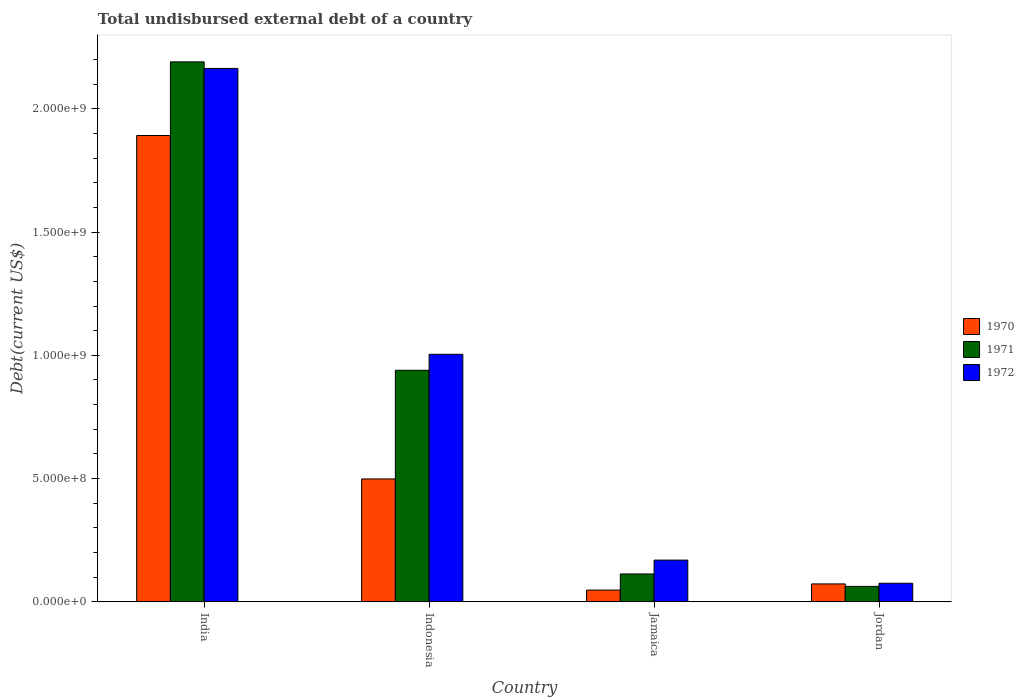How many different coloured bars are there?
Your answer should be very brief. 3. How many groups of bars are there?
Ensure brevity in your answer.  4. Are the number of bars per tick equal to the number of legend labels?
Your response must be concise. Yes. Are the number of bars on each tick of the X-axis equal?
Give a very brief answer. Yes. How many bars are there on the 2nd tick from the left?
Your response must be concise. 3. How many bars are there on the 1st tick from the right?
Offer a very short reply. 3. What is the label of the 3rd group of bars from the left?
Give a very brief answer. Jamaica. In how many cases, is the number of bars for a given country not equal to the number of legend labels?
Offer a very short reply. 0. What is the total undisbursed external debt in 1970 in Jordan?
Provide a succinct answer. 7.28e+07. Across all countries, what is the maximum total undisbursed external debt in 1971?
Provide a succinct answer. 2.19e+09. Across all countries, what is the minimum total undisbursed external debt in 1971?
Your answer should be very brief. 6.28e+07. In which country was the total undisbursed external debt in 1970 minimum?
Offer a very short reply. Jamaica. What is the total total undisbursed external debt in 1971 in the graph?
Ensure brevity in your answer.  3.31e+09. What is the difference between the total undisbursed external debt in 1970 in Indonesia and that in Jordan?
Your response must be concise. 4.26e+08. What is the difference between the total undisbursed external debt in 1970 in Jamaica and the total undisbursed external debt in 1972 in India?
Keep it short and to the point. -2.12e+09. What is the average total undisbursed external debt in 1970 per country?
Your answer should be very brief. 6.28e+08. What is the difference between the total undisbursed external debt of/in 1971 and total undisbursed external debt of/in 1972 in Jordan?
Ensure brevity in your answer.  -1.28e+07. In how many countries, is the total undisbursed external debt in 1970 greater than 600000000 US$?
Provide a succinct answer. 1. What is the ratio of the total undisbursed external debt in 1972 in Jamaica to that in Jordan?
Offer a terse response. 2.24. Is the total undisbursed external debt in 1972 in India less than that in Jamaica?
Provide a short and direct response. No. Is the difference between the total undisbursed external debt in 1971 in Indonesia and Jordan greater than the difference between the total undisbursed external debt in 1972 in Indonesia and Jordan?
Give a very brief answer. No. What is the difference between the highest and the second highest total undisbursed external debt in 1971?
Offer a terse response. 8.26e+08. What is the difference between the highest and the lowest total undisbursed external debt in 1971?
Keep it short and to the point. 2.13e+09. In how many countries, is the total undisbursed external debt in 1971 greater than the average total undisbursed external debt in 1971 taken over all countries?
Your response must be concise. 2. What does the 2nd bar from the left in Jamaica represents?
Make the answer very short. 1971. What does the 3rd bar from the right in Jamaica represents?
Your answer should be very brief. 1970. How many bars are there?
Make the answer very short. 12. How many countries are there in the graph?
Ensure brevity in your answer.  4. What is the difference between two consecutive major ticks on the Y-axis?
Make the answer very short. 5.00e+08. Does the graph contain any zero values?
Ensure brevity in your answer.  No. What is the title of the graph?
Keep it short and to the point. Total undisbursed external debt of a country. What is the label or title of the Y-axis?
Provide a short and direct response. Debt(current US$). What is the Debt(current US$) in 1970 in India?
Your answer should be very brief. 1.89e+09. What is the Debt(current US$) in 1971 in India?
Provide a succinct answer. 2.19e+09. What is the Debt(current US$) of 1972 in India?
Make the answer very short. 2.16e+09. What is the Debt(current US$) of 1970 in Indonesia?
Keep it short and to the point. 4.99e+08. What is the Debt(current US$) of 1971 in Indonesia?
Keep it short and to the point. 9.39e+08. What is the Debt(current US$) of 1972 in Indonesia?
Offer a terse response. 1.00e+09. What is the Debt(current US$) of 1970 in Jamaica?
Provide a succinct answer. 4.78e+07. What is the Debt(current US$) of 1971 in Jamaica?
Your answer should be very brief. 1.13e+08. What is the Debt(current US$) of 1972 in Jamaica?
Make the answer very short. 1.69e+08. What is the Debt(current US$) of 1970 in Jordan?
Ensure brevity in your answer.  7.28e+07. What is the Debt(current US$) of 1971 in Jordan?
Make the answer very short. 6.28e+07. What is the Debt(current US$) in 1972 in Jordan?
Provide a succinct answer. 7.56e+07. Across all countries, what is the maximum Debt(current US$) in 1970?
Keep it short and to the point. 1.89e+09. Across all countries, what is the maximum Debt(current US$) of 1971?
Offer a very short reply. 2.19e+09. Across all countries, what is the maximum Debt(current US$) in 1972?
Give a very brief answer. 2.16e+09. Across all countries, what is the minimum Debt(current US$) of 1970?
Ensure brevity in your answer.  4.78e+07. Across all countries, what is the minimum Debt(current US$) of 1971?
Offer a terse response. 6.28e+07. Across all countries, what is the minimum Debt(current US$) in 1972?
Keep it short and to the point. 7.56e+07. What is the total Debt(current US$) in 1970 in the graph?
Your response must be concise. 2.51e+09. What is the total Debt(current US$) of 1971 in the graph?
Make the answer very short. 3.31e+09. What is the total Debt(current US$) in 1972 in the graph?
Your response must be concise. 3.41e+09. What is the difference between the Debt(current US$) in 1970 in India and that in Indonesia?
Offer a terse response. 1.39e+09. What is the difference between the Debt(current US$) of 1971 in India and that in Indonesia?
Make the answer very short. 1.25e+09. What is the difference between the Debt(current US$) in 1972 in India and that in Indonesia?
Your response must be concise. 1.16e+09. What is the difference between the Debt(current US$) of 1970 in India and that in Jamaica?
Provide a short and direct response. 1.84e+09. What is the difference between the Debt(current US$) in 1971 in India and that in Jamaica?
Provide a succinct answer. 2.08e+09. What is the difference between the Debt(current US$) of 1972 in India and that in Jamaica?
Offer a terse response. 1.99e+09. What is the difference between the Debt(current US$) in 1970 in India and that in Jordan?
Keep it short and to the point. 1.82e+09. What is the difference between the Debt(current US$) in 1971 in India and that in Jordan?
Your answer should be compact. 2.13e+09. What is the difference between the Debt(current US$) of 1972 in India and that in Jordan?
Give a very brief answer. 2.09e+09. What is the difference between the Debt(current US$) in 1970 in Indonesia and that in Jamaica?
Make the answer very short. 4.51e+08. What is the difference between the Debt(current US$) of 1971 in Indonesia and that in Jamaica?
Make the answer very short. 8.26e+08. What is the difference between the Debt(current US$) of 1972 in Indonesia and that in Jamaica?
Your answer should be very brief. 8.35e+08. What is the difference between the Debt(current US$) of 1970 in Indonesia and that in Jordan?
Keep it short and to the point. 4.26e+08. What is the difference between the Debt(current US$) in 1971 in Indonesia and that in Jordan?
Make the answer very short. 8.76e+08. What is the difference between the Debt(current US$) of 1972 in Indonesia and that in Jordan?
Your answer should be very brief. 9.29e+08. What is the difference between the Debt(current US$) of 1970 in Jamaica and that in Jordan?
Provide a short and direct response. -2.50e+07. What is the difference between the Debt(current US$) in 1971 in Jamaica and that in Jordan?
Offer a very short reply. 5.05e+07. What is the difference between the Debt(current US$) in 1972 in Jamaica and that in Jordan?
Your answer should be very brief. 9.38e+07. What is the difference between the Debt(current US$) of 1970 in India and the Debt(current US$) of 1971 in Indonesia?
Give a very brief answer. 9.52e+08. What is the difference between the Debt(current US$) in 1970 in India and the Debt(current US$) in 1972 in Indonesia?
Provide a succinct answer. 8.87e+08. What is the difference between the Debt(current US$) of 1971 in India and the Debt(current US$) of 1972 in Indonesia?
Make the answer very short. 1.19e+09. What is the difference between the Debt(current US$) of 1970 in India and the Debt(current US$) of 1971 in Jamaica?
Ensure brevity in your answer.  1.78e+09. What is the difference between the Debt(current US$) of 1970 in India and the Debt(current US$) of 1972 in Jamaica?
Your answer should be compact. 1.72e+09. What is the difference between the Debt(current US$) in 1971 in India and the Debt(current US$) in 1972 in Jamaica?
Your answer should be very brief. 2.02e+09. What is the difference between the Debt(current US$) of 1970 in India and the Debt(current US$) of 1971 in Jordan?
Provide a succinct answer. 1.83e+09. What is the difference between the Debt(current US$) of 1970 in India and the Debt(current US$) of 1972 in Jordan?
Ensure brevity in your answer.  1.82e+09. What is the difference between the Debt(current US$) in 1971 in India and the Debt(current US$) in 1972 in Jordan?
Offer a terse response. 2.11e+09. What is the difference between the Debt(current US$) of 1970 in Indonesia and the Debt(current US$) of 1971 in Jamaica?
Make the answer very short. 3.85e+08. What is the difference between the Debt(current US$) in 1970 in Indonesia and the Debt(current US$) in 1972 in Jamaica?
Your answer should be very brief. 3.29e+08. What is the difference between the Debt(current US$) of 1971 in Indonesia and the Debt(current US$) of 1972 in Jamaica?
Ensure brevity in your answer.  7.70e+08. What is the difference between the Debt(current US$) in 1970 in Indonesia and the Debt(current US$) in 1971 in Jordan?
Provide a succinct answer. 4.36e+08. What is the difference between the Debt(current US$) of 1970 in Indonesia and the Debt(current US$) of 1972 in Jordan?
Your response must be concise. 4.23e+08. What is the difference between the Debt(current US$) of 1971 in Indonesia and the Debt(current US$) of 1972 in Jordan?
Provide a short and direct response. 8.64e+08. What is the difference between the Debt(current US$) of 1970 in Jamaica and the Debt(current US$) of 1971 in Jordan?
Your answer should be very brief. -1.50e+07. What is the difference between the Debt(current US$) in 1970 in Jamaica and the Debt(current US$) in 1972 in Jordan?
Offer a very short reply. -2.78e+07. What is the difference between the Debt(current US$) of 1971 in Jamaica and the Debt(current US$) of 1972 in Jordan?
Your answer should be compact. 3.76e+07. What is the average Debt(current US$) in 1970 per country?
Ensure brevity in your answer.  6.28e+08. What is the average Debt(current US$) in 1971 per country?
Keep it short and to the point. 8.26e+08. What is the average Debt(current US$) in 1972 per country?
Provide a succinct answer. 8.53e+08. What is the difference between the Debt(current US$) of 1970 and Debt(current US$) of 1971 in India?
Your answer should be very brief. -2.99e+08. What is the difference between the Debt(current US$) of 1970 and Debt(current US$) of 1972 in India?
Your response must be concise. -2.72e+08. What is the difference between the Debt(current US$) of 1971 and Debt(current US$) of 1972 in India?
Make the answer very short. 2.66e+07. What is the difference between the Debt(current US$) of 1970 and Debt(current US$) of 1971 in Indonesia?
Keep it short and to the point. -4.41e+08. What is the difference between the Debt(current US$) of 1970 and Debt(current US$) of 1972 in Indonesia?
Your response must be concise. -5.06e+08. What is the difference between the Debt(current US$) in 1971 and Debt(current US$) in 1972 in Indonesia?
Provide a succinct answer. -6.49e+07. What is the difference between the Debt(current US$) of 1970 and Debt(current US$) of 1971 in Jamaica?
Give a very brief answer. -6.54e+07. What is the difference between the Debt(current US$) in 1970 and Debt(current US$) in 1972 in Jamaica?
Give a very brief answer. -1.22e+08. What is the difference between the Debt(current US$) of 1971 and Debt(current US$) of 1972 in Jamaica?
Your answer should be compact. -5.62e+07. What is the difference between the Debt(current US$) in 1970 and Debt(current US$) in 1971 in Jordan?
Your answer should be compact. 1.01e+07. What is the difference between the Debt(current US$) of 1970 and Debt(current US$) of 1972 in Jordan?
Make the answer very short. -2.75e+06. What is the difference between the Debt(current US$) of 1971 and Debt(current US$) of 1972 in Jordan?
Your answer should be compact. -1.28e+07. What is the ratio of the Debt(current US$) in 1970 in India to that in Indonesia?
Provide a succinct answer. 3.79. What is the ratio of the Debt(current US$) of 1971 in India to that in Indonesia?
Ensure brevity in your answer.  2.33. What is the ratio of the Debt(current US$) in 1972 in India to that in Indonesia?
Give a very brief answer. 2.15. What is the ratio of the Debt(current US$) of 1970 in India to that in Jamaica?
Keep it short and to the point. 39.58. What is the ratio of the Debt(current US$) of 1971 in India to that in Jamaica?
Ensure brevity in your answer.  19.35. What is the ratio of the Debt(current US$) in 1972 in India to that in Jamaica?
Your response must be concise. 12.77. What is the ratio of the Debt(current US$) in 1970 in India to that in Jordan?
Give a very brief answer. 25.97. What is the ratio of the Debt(current US$) in 1971 in India to that in Jordan?
Give a very brief answer. 34.9. What is the ratio of the Debt(current US$) in 1972 in India to that in Jordan?
Make the answer very short. 28.62. What is the ratio of the Debt(current US$) of 1970 in Indonesia to that in Jamaica?
Provide a succinct answer. 10.43. What is the ratio of the Debt(current US$) of 1971 in Indonesia to that in Jamaica?
Your answer should be very brief. 8.3. What is the ratio of the Debt(current US$) in 1972 in Indonesia to that in Jamaica?
Make the answer very short. 5.93. What is the ratio of the Debt(current US$) of 1970 in Indonesia to that in Jordan?
Ensure brevity in your answer.  6.84. What is the ratio of the Debt(current US$) in 1971 in Indonesia to that in Jordan?
Your answer should be compact. 14.97. What is the ratio of the Debt(current US$) of 1972 in Indonesia to that in Jordan?
Your response must be concise. 13.28. What is the ratio of the Debt(current US$) in 1970 in Jamaica to that in Jordan?
Provide a short and direct response. 0.66. What is the ratio of the Debt(current US$) in 1971 in Jamaica to that in Jordan?
Offer a terse response. 1.8. What is the ratio of the Debt(current US$) of 1972 in Jamaica to that in Jordan?
Keep it short and to the point. 2.24. What is the difference between the highest and the second highest Debt(current US$) of 1970?
Keep it short and to the point. 1.39e+09. What is the difference between the highest and the second highest Debt(current US$) in 1971?
Your answer should be very brief. 1.25e+09. What is the difference between the highest and the second highest Debt(current US$) of 1972?
Offer a very short reply. 1.16e+09. What is the difference between the highest and the lowest Debt(current US$) in 1970?
Give a very brief answer. 1.84e+09. What is the difference between the highest and the lowest Debt(current US$) of 1971?
Provide a succinct answer. 2.13e+09. What is the difference between the highest and the lowest Debt(current US$) of 1972?
Your answer should be very brief. 2.09e+09. 